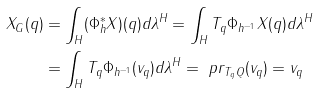<formula> <loc_0><loc_0><loc_500><loc_500>X _ { G } ( q ) & = \int _ { H } ( \Phi _ { h } ^ { * } X ) ( q ) d \lambda ^ { H } = \int _ { H } T _ { q } \Phi _ { h ^ { - 1 } } X ( q ) d \lambda ^ { H } \\ & = \int _ { H } T _ { q } \Phi _ { h ^ { - 1 } } ( v _ { q } ) d \lambda ^ { H } = \ p r _ { T _ { q } Q } ( v _ { q } ) = v _ { q }</formula> 